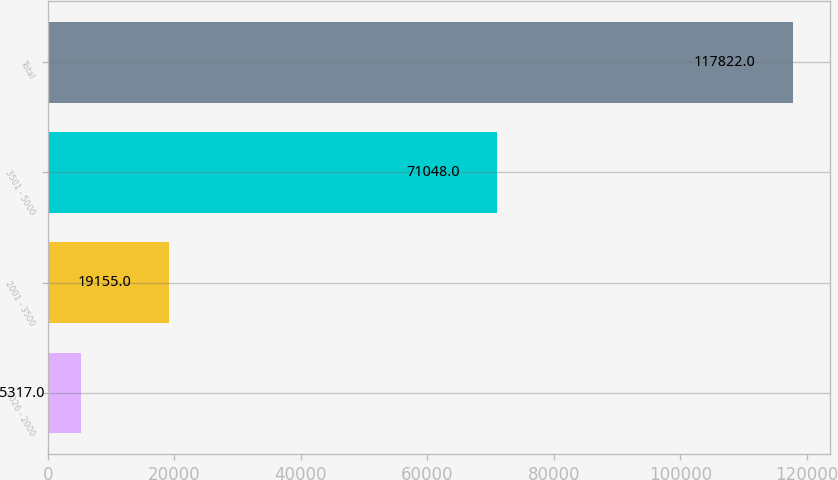Convert chart to OTSL. <chart><loc_0><loc_0><loc_500><loc_500><bar_chart><fcel>1026 - 2000<fcel>2001 - 3500<fcel>3501 - 5000<fcel>Total<nl><fcel>5317<fcel>19155<fcel>71048<fcel>117822<nl></chart> 